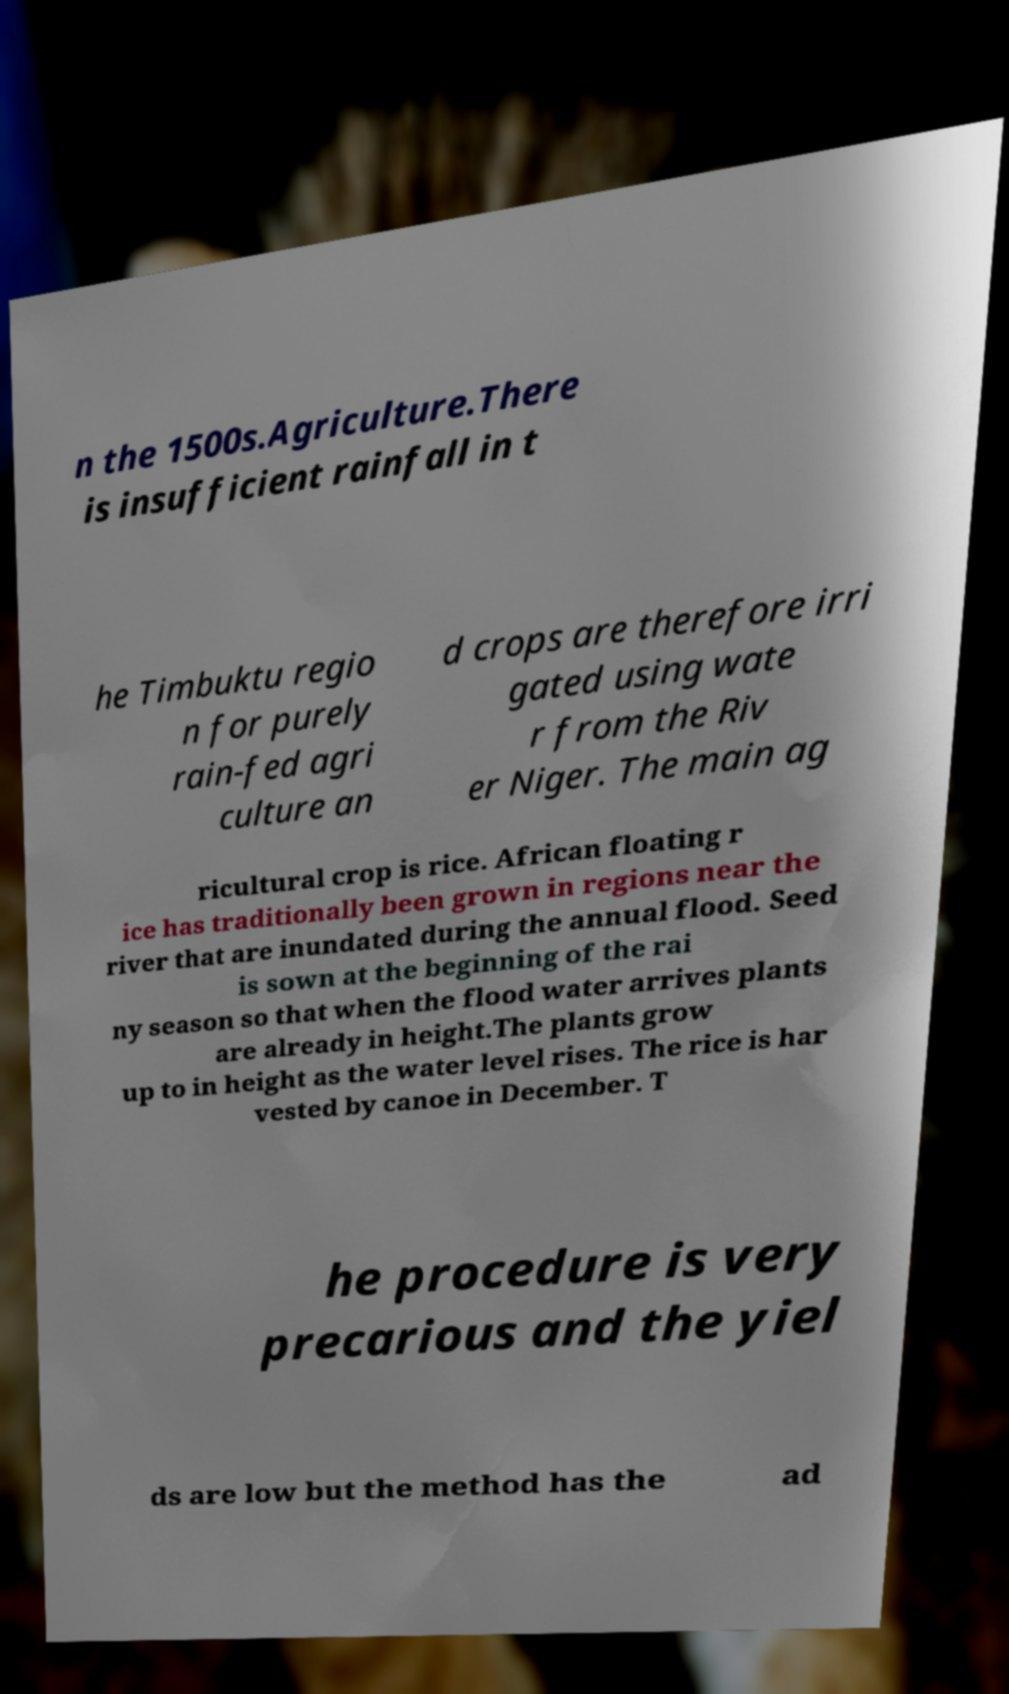Please identify and transcribe the text found in this image. n the 1500s.Agriculture.There is insufficient rainfall in t he Timbuktu regio n for purely rain-fed agri culture an d crops are therefore irri gated using wate r from the Riv er Niger. The main ag ricultural crop is rice. African floating r ice has traditionally been grown in regions near the river that are inundated during the annual flood. Seed is sown at the beginning of the rai ny season so that when the flood water arrives plants are already in height.The plants grow up to in height as the water level rises. The rice is har vested by canoe in December. T he procedure is very precarious and the yiel ds are low but the method has the ad 